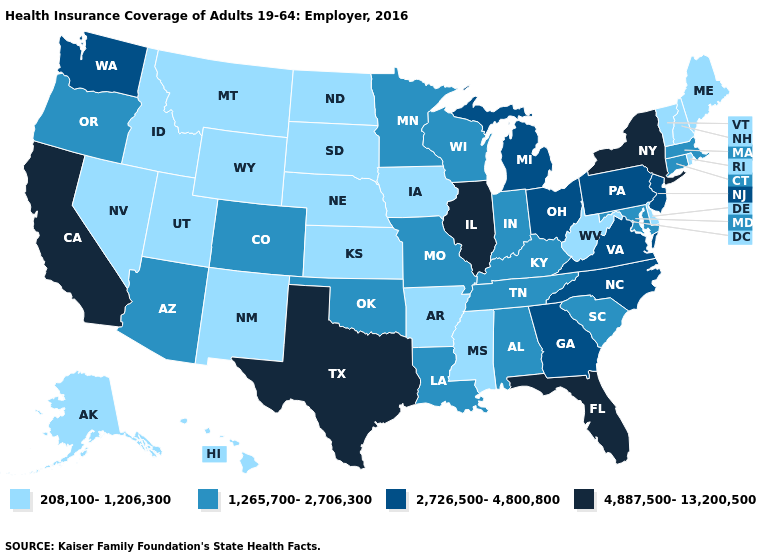Does Michigan have the same value as New Jersey?
Short answer required. Yes. What is the value of New Jersey?
Concise answer only. 2,726,500-4,800,800. Name the states that have a value in the range 2,726,500-4,800,800?
Short answer required. Georgia, Michigan, New Jersey, North Carolina, Ohio, Pennsylvania, Virginia, Washington. Among the states that border Kentucky , does Illinois have the lowest value?
Write a very short answer. No. What is the lowest value in the MidWest?
Concise answer only. 208,100-1,206,300. Does Texas have the highest value in the South?
Quick response, please. Yes. Name the states that have a value in the range 4,887,500-13,200,500?
Quick response, please. California, Florida, Illinois, New York, Texas. Does Alaska have a lower value than Kentucky?
Quick response, please. Yes. Name the states that have a value in the range 4,887,500-13,200,500?
Quick response, please. California, Florida, Illinois, New York, Texas. Which states have the highest value in the USA?
Concise answer only. California, Florida, Illinois, New York, Texas. What is the value of South Carolina?
Be succinct. 1,265,700-2,706,300. What is the value of Maryland?
Quick response, please. 1,265,700-2,706,300. What is the value of Michigan?
Quick response, please. 2,726,500-4,800,800. What is the value of Alabama?
Quick response, please. 1,265,700-2,706,300. What is the value of Oklahoma?
Concise answer only. 1,265,700-2,706,300. 